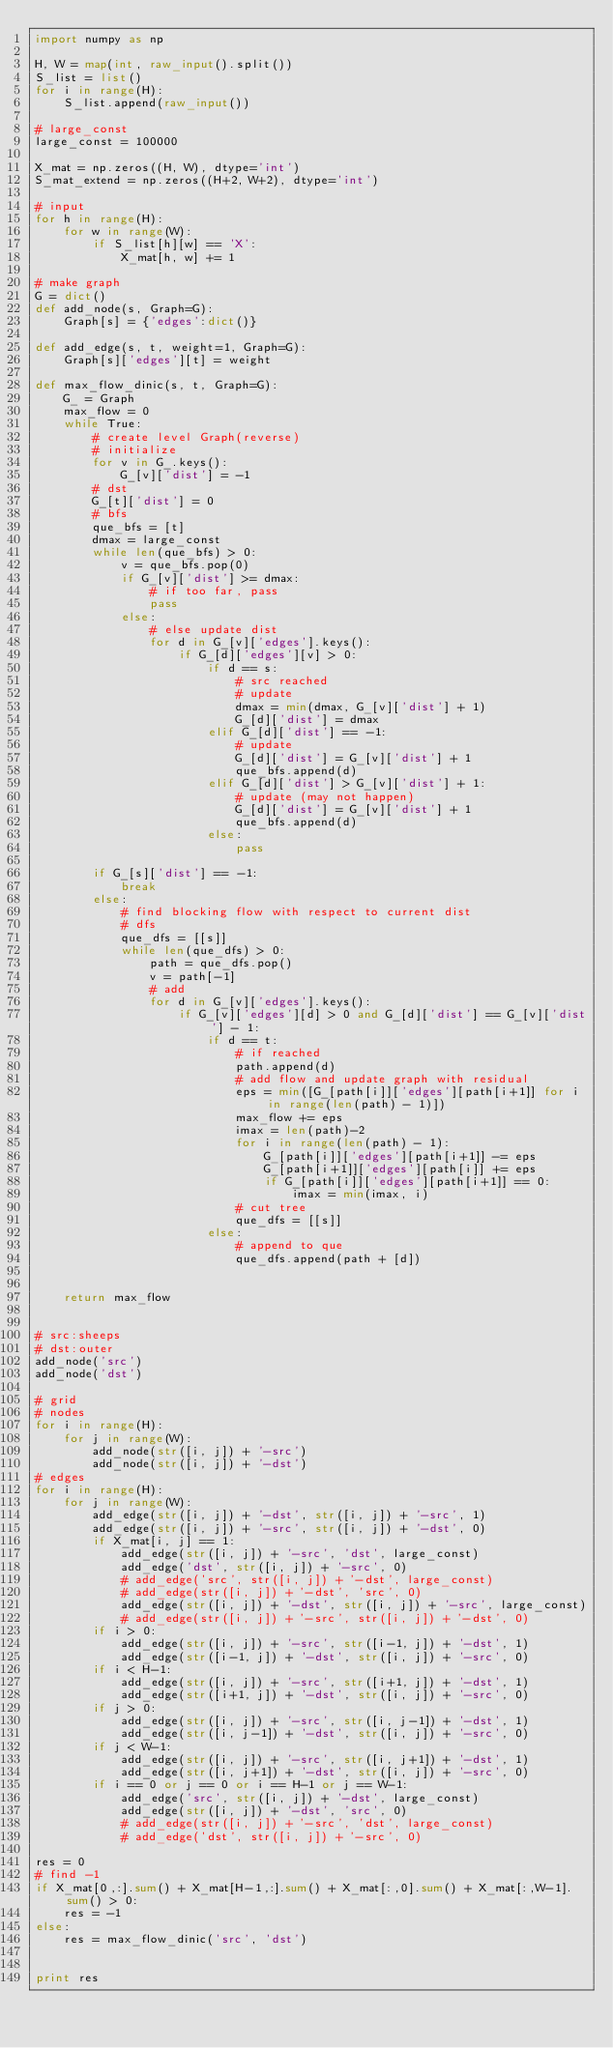<code> <loc_0><loc_0><loc_500><loc_500><_Python_>import numpy as np

H, W = map(int, raw_input().split())
S_list = list()
for i in range(H):
    S_list.append(raw_input())

# large_const
large_const = 100000

X_mat = np.zeros((H, W), dtype='int')
S_mat_extend = np.zeros((H+2, W+2), dtype='int')

# input
for h in range(H):
    for w in range(W):
        if S_list[h][w] == 'X':
            X_mat[h, w] += 1

# make graph
G = dict()
def add_node(s, Graph=G):
    Graph[s] = {'edges':dict()}
    
def add_edge(s, t, weight=1, Graph=G):
    Graph[s]['edges'][t] = weight

def max_flow_dinic(s, t, Graph=G):
    G_ = Graph
    max_flow = 0
    while True:
        # create level Graph(reverse)
        # initialize
        for v in G_.keys():
            G_[v]['dist'] = -1
        # dst
        G_[t]['dist'] = 0
        # bfs 
        que_bfs = [t]
        dmax = large_const
        while len(que_bfs) > 0:
            v = que_bfs.pop(0)
            if G_[v]['dist'] >= dmax:
                # if too far, pass
                pass
            else:
                # else update dist
                for d in G_[v]['edges'].keys():    
                    if G_[d]['edges'][v] > 0:
                        if d == s:
                            # src reached
                            # update
                            dmax = min(dmax, G_[v]['dist'] + 1)
                            G_[d]['dist'] = dmax
                        elif G_[d]['dist'] == -1:
                            # update
                            G_[d]['dist'] = G_[v]['dist'] + 1
                            que_bfs.append(d)
                        elif G_[d]['dist'] > G_[v]['dist'] + 1:
                            # update (may not happen)
                            G_[d]['dist'] = G_[v]['dist'] + 1
                            que_bfs.append(d)
                        else:
                            pass
        
        if G_[s]['dist'] == -1:
            break
        else:
            # find blocking flow with respect to current dist
            # dfs
            que_dfs = [[s]]
            while len(que_dfs) > 0:
                path = que_dfs.pop()
                v = path[-1]
                # add
                for d in G_[v]['edges'].keys():
                    if G_[v]['edges'][d] > 0 and G_[d]['dist'] == G_[v]['dist'] - 1:
                        if d == t:
                            # if reached
                            path.append(d)
                            # add flow and update graph with residual
                            eps = min([G_[path[i]]['edges'][path[i+1]] for i in range(len(path) - 1)])
                            max_flow += eps
                            imax = len(path)-2
                            for i in range(len(path) - 1):
                                G_[path[i]]['edges'][path[i+1]] -= eps
                                G_[path[i+1]]['edges'][path[i]] += eps
                                if G_[path[i]]['edges'][path[i+1]] == 0:
                                    imax = min(imax, i)
                            # cut tree
                            que_dfs = [[s]]
                        else:
                            # append to que
                            que_dfs.append(path + [d])
            
    
    return max_flow


# src:sheeps
# dst:outer
add_node('src')
add_node('dst')

# grid
# nodes
for i in range(H):
    for j in range(W):
        add_node(str([i, j]) + '-src')
        add_node(str([i, j]) + '-dst')
# edges
for i in range(H):
    for j in range(W):
        add_edge(str([i, j]) + '-dst', str([i, j]) + '-src', 1)
        add_edge(str([i, j]) + '-src', str([i, j]) + '-dst', 0)
        if X_mat[i, j] == 1:
            add_edge(str([i, j]) + '-src', 'dst', large_const)
            add_edge('dst', str([i, j]) + '-src', 0)
            # add_edge('src', str([i, j]) + '-dst', large_const)
            # add_edge(str([i, j]) + '-dst', 'src', 0)
            add_edge(str([i, j]) + '-dst', str([i, j]) + '-src', large_const)
            # add_edge(str([i, j]) + '-src', str([i, j]) + '-dst', 0)
        if i > 0:
            add_edge(str([i, j]) + '-src', str([i-1, j]) + '-dst', 1)
            add_edge(str([i-1, j]) + '-dst', str([i, j]) + '-src', 0)
        if i < H-1:
            add_edge(str([i, j]) + '-src', str([i+1, j]) + '-dst', 1)
            add_edge(str([i+1, j]) + '-dst', str([i, j]) + '-src', 0)
        if j > 0:
            add_edge(str([i, j]) + '-src', str([i, j-1]) + '-dst', 1)
            add_edge(str([i, j-1]) + '-dst', str([i, j]) + '-src', 0)
        if j < W-1:
            add_edge(str([i, j]) + '-src', str([i, j+1]) + '-dst', 1)
            add_edge(str([i, j+1]) + '-dst', str([i, j]) + '-src', 0)
        if i == 0 or j == 0 or i == H-1 or j == W-1:
            add_edge('src', str([i, j]) + '-dst', large_const)
            add_edge(str([i, j]) + '-dst', 'src', 0)
            # add_edge(str([i, j]) + '-src', 'dst', large_const)
            # add_edge('dst', str([i, j]) + '-src', 0)

res = 0
# find -1
if X_mat[0,:].sum() + X_mat[H-1,:].sum() + X_mat[:,0].sum() + X_mat[:,W-1].sum() > 0:
    res = -1
else:
    res = max_flow_dinic('src', 'dst')


print res</code> 